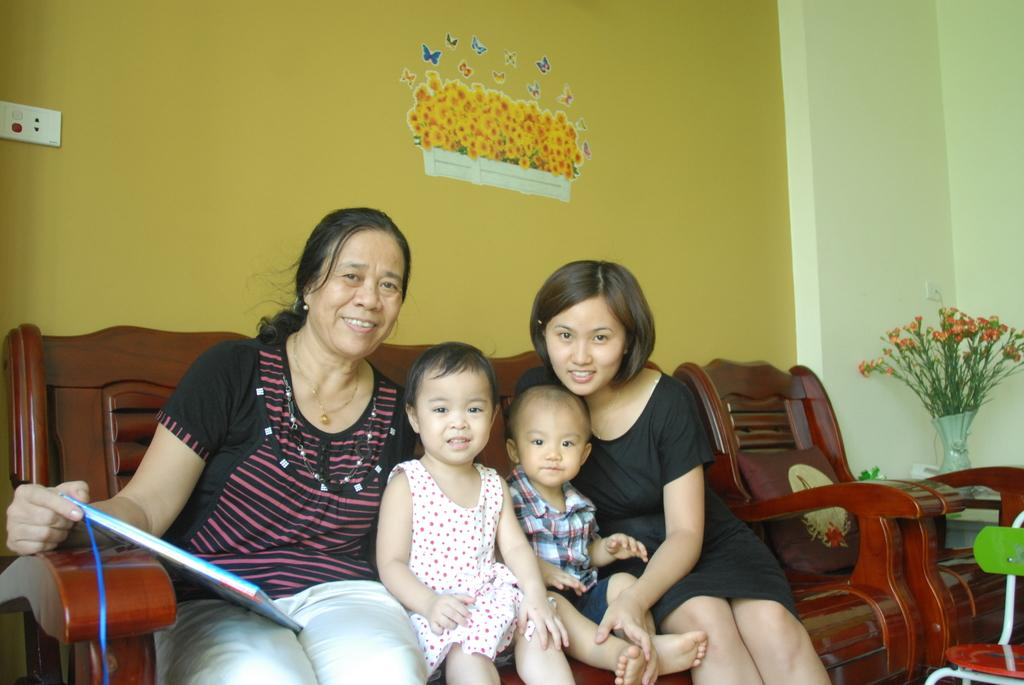How many people are in the image? There are four people in the image, two ladies and two kids. What are the ladies and kids doing in the image? The ladies and kids are sitting on a sofa. What can be seen on the wall in the image? There is a wall poster visible in the image. What decorative item can be seen in the image? There is a flower vase in the image. What type of harbor can be seen in the background of the image? There is no harbor visible in the image; it features a group of people sitting on a sofa with a wall poster and a flower vase. 